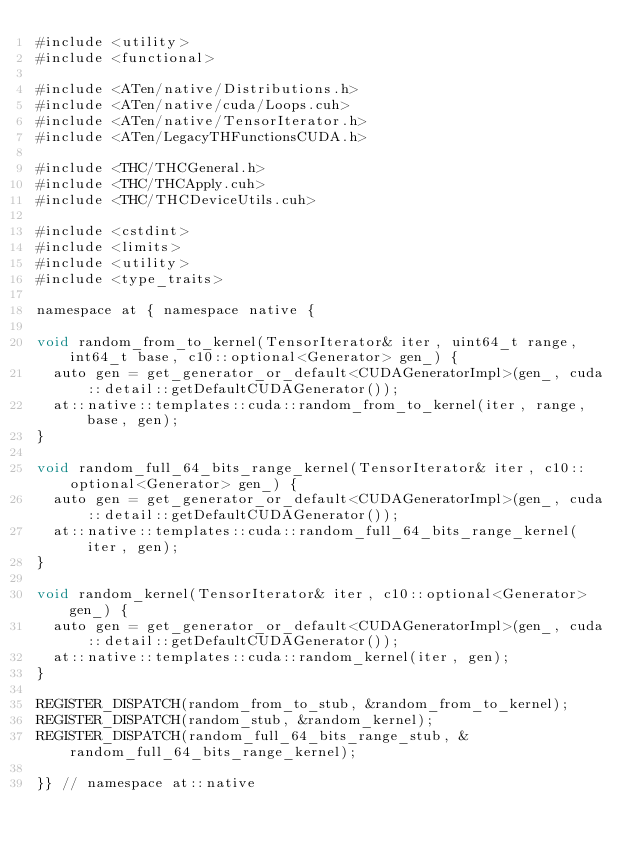Convert code to text. <code><loc_0><loc_0><loc_500><loc_500><_Cuda_>#include <utility>
#include <functional>

#include <ATen/native/Distributions.h>
#include <ATen/native/cuda/Loops.cuh>
#include <ATen/native/TensorIterator.h>
#include <ATen/LegacyTHFunctionsCUDA.h>

#include <THC/THCGeneral.h>
#include <THC/THCApply.cuh>
#include <THC/THCDeviceUtils.cuh>

#include <cstdint>
#include <limits>
#include <utility>
#include <type_traits>

namespace at { namespace native {

void random_from_to_kernel(TensorIterator& iter, uint64_t range, int64_t base, c10::optional<Generator> gen_) {
  auto gen = get_generator_or_default<CUDAGeneratorImpl>(gen_, cuda::detail::getDefaultCUDAGenerator());
  at::native::templates::cuda::random_from_to_kernel(iter, range, base, gen);
}

void random_full_64_bits_range_kernel(TensorIterator& iter, c10::optional<Generator> gen_) {
  auto gen = get_generator_or_default<CUDAGeneratorImpl>(gen_, cuda::detail::getDefaultCUDAGenerator());
  at::native::templates::cuda::random_full_64_bits_range_kernel(iter, gen);
}

void random_kernel(TensorIterator& iter, c10::optional<Generator> gen_) {
  auto gen = get_generator_or_default<CUDAGeneratorImpl>(gen_, cuda::detail::getDefaultCUDAGenerator());
  at::native::templates::cuda::random_kernel(iter, gen);
}

REGISTER_DISPATCH(random_from_to_stub, &random_from_to_kernel);
REGISTER_DISPATCH(random_stub, &random_kernel);
REGISTER_DISPATCH(random_full_64_bits_range_stub, &random_full_64_bits_range_kernel);

}} // namespace at::native
</code> 